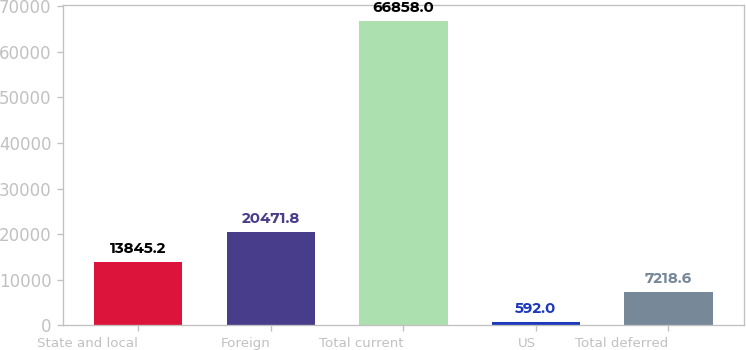<chart> <loc_0><loc_0><loc_500><loc_500><bar_chart><fcel>State and local<fcel>Foreign<fcel>Total current<fcel>US<fcel>Total deferred<nl><fcel>13845.2<fcel>20471.8<fcel>66858<fcel>592<fcel>7218.6<nl></chart> 